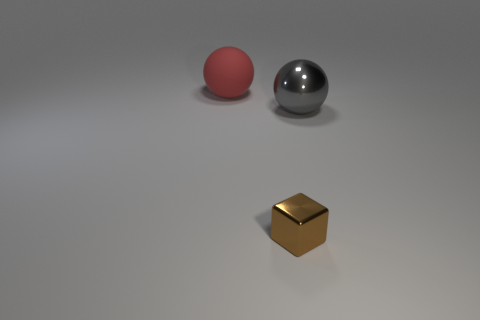Add 2 purple matte blocks. How many objects exist? 5 Subtract all balls. How many objects are left? 1 Add 3 gray objects. How many gray objects are left? 4 Add 3 large brown matte blocks. How many large brown matte blocks exist? 3 Subtract 0 green balls. How many objects are left? 3 Subtract all gray balls. Subtract all large gray rubber cylinders. How many objects are left? 2 